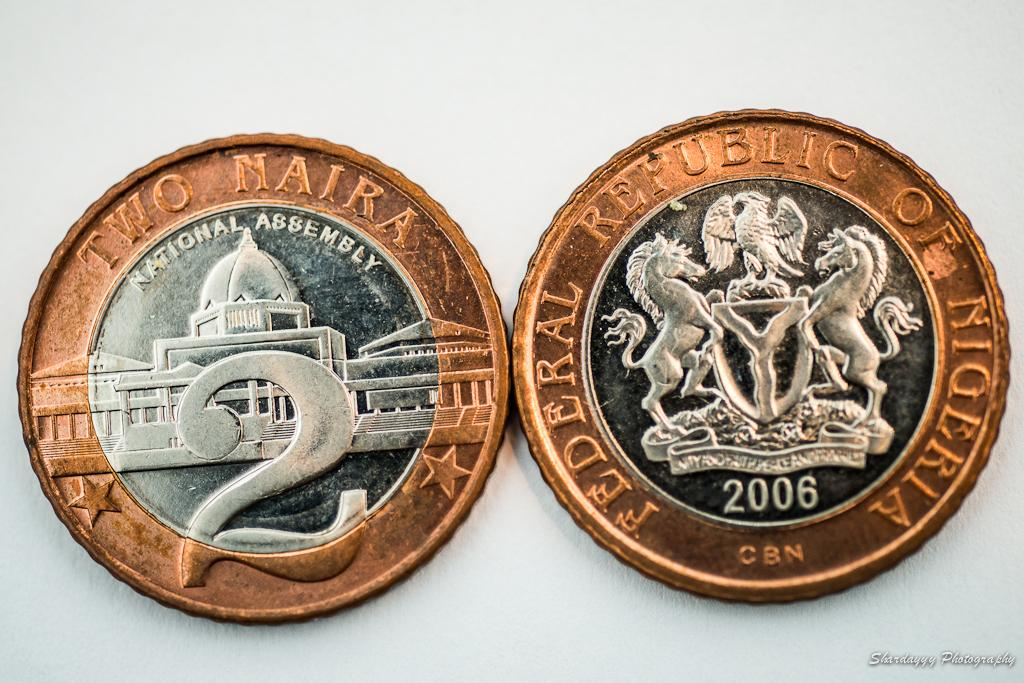<image>
Render a clear and concise summary of the photo. Both sides of a Two Naira coin from Nigera are shown side by side. 